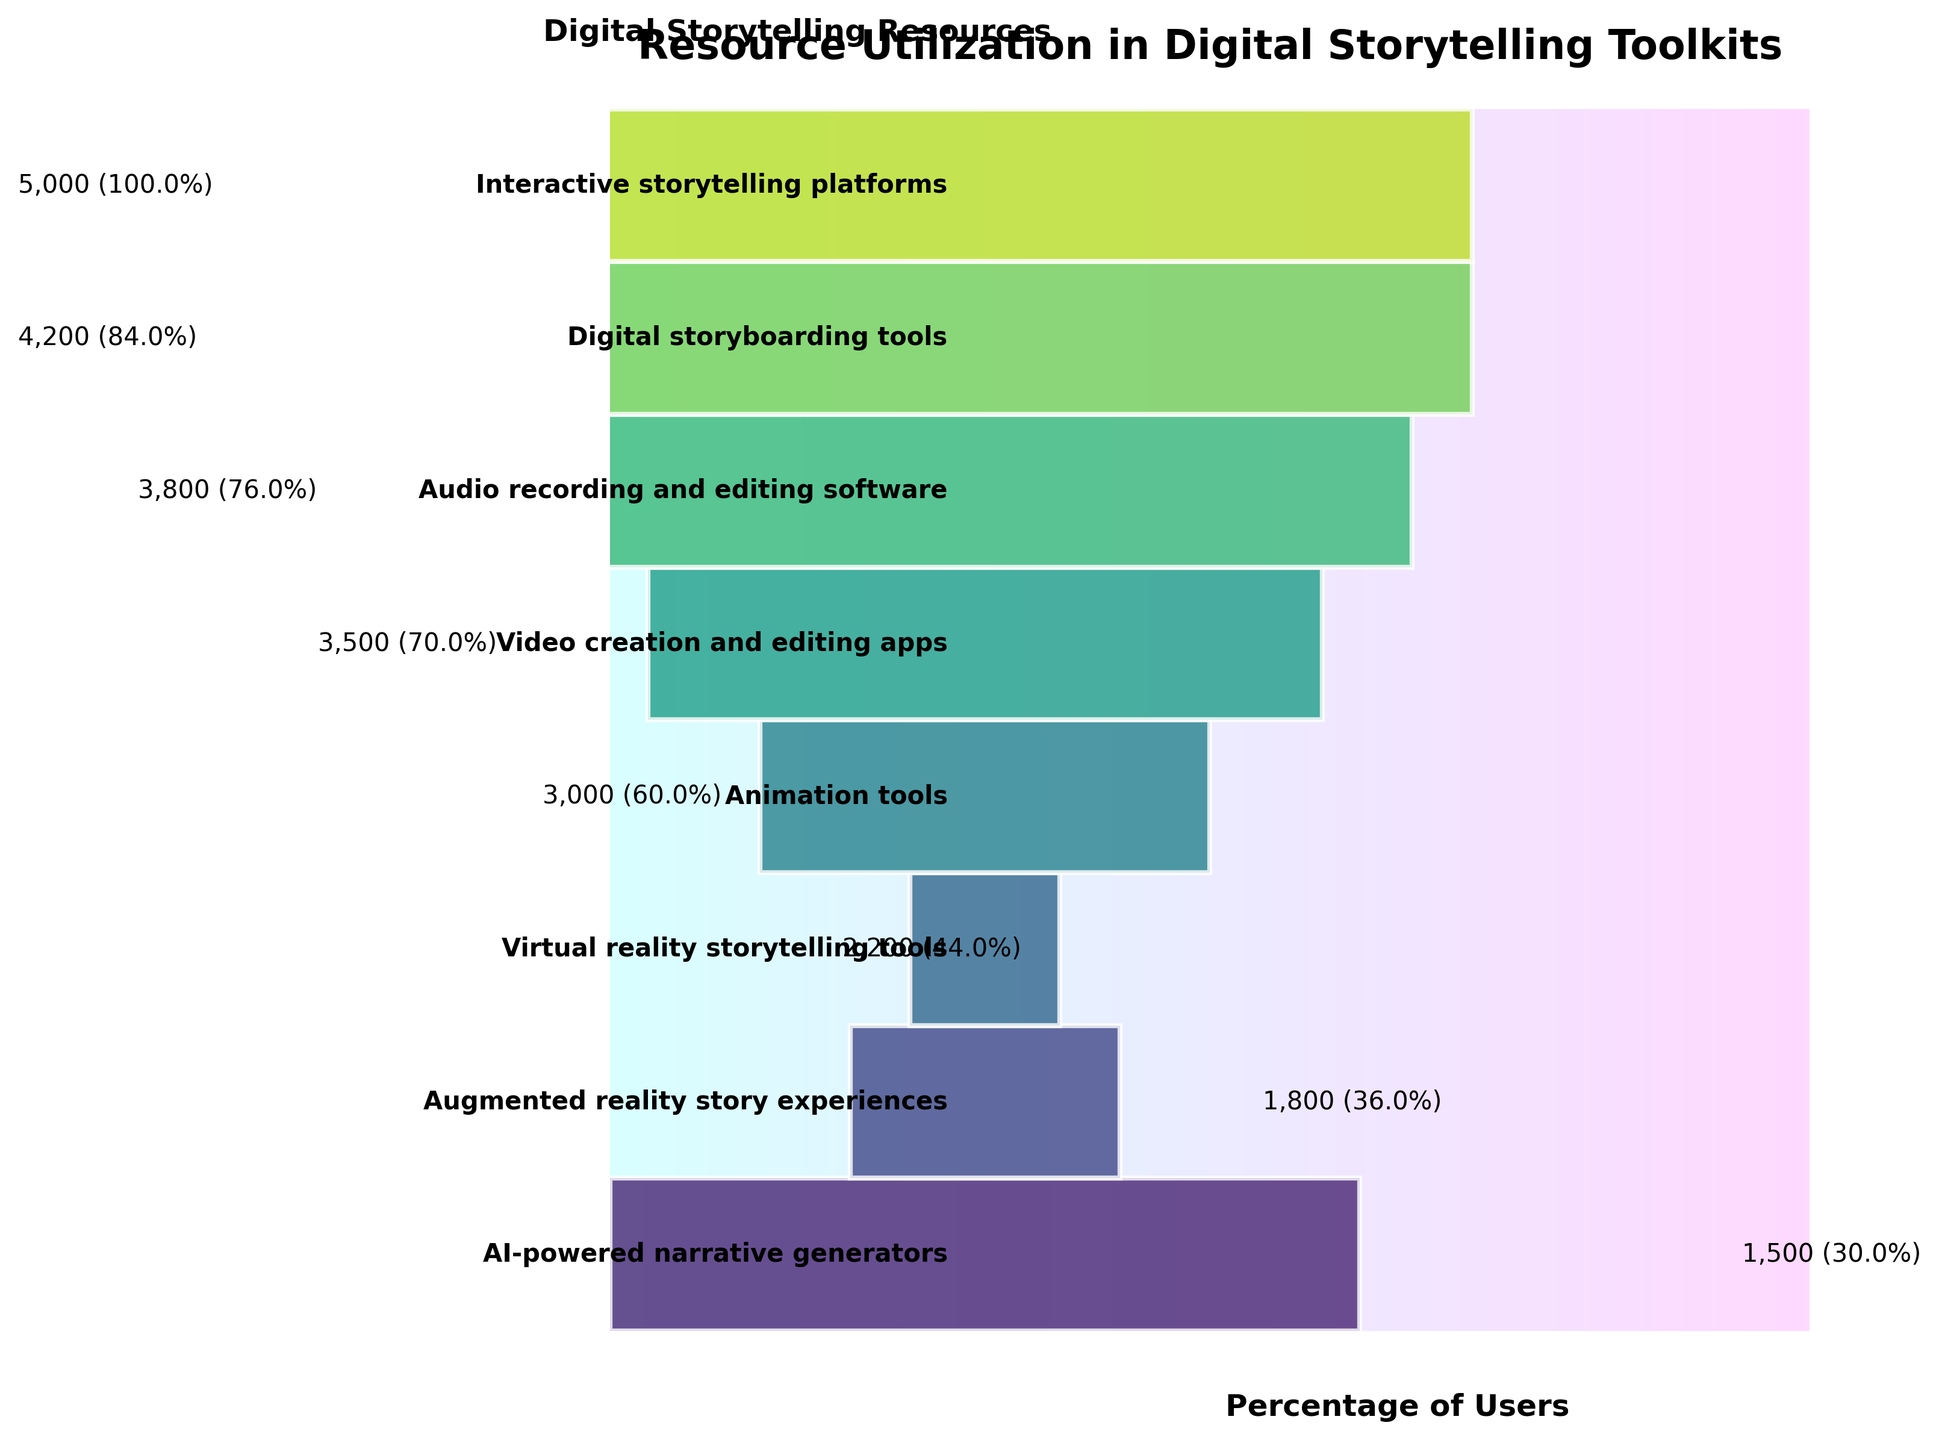What is the title of the chart? The title is usually displayed at the top of the chart. Reading the chart, the title clearly states the main topic of the visualization.
Answer: Resource Utilization in Digital Storytelling Toolkits How many resources are listed in the funnel chart? To determine this, count the number of distinct resource categories shown in the funnel chart.
Answer: 8 Which resource has the highest percentage of users? Find the segment with the widest width and observe the label associated with it. The highest percentage is the starting point of the funnel.
Answer: Interactive storytelling platforms How many users utilize Virtual reality storytelling tools? Locate the segment labeled "Virtual reality storytelling tools" and refer to the user count written next to it.
Answer: 2200 What is the difference in user count between Audio recording and editing software and Augmented reality story experiences? Identify the user counts for both resources from the segments and subtract the lower number from the higher number: 3800 - 1800.
Answer: 2000 What percentage of users utilize AI-powered narrative generators? Locate the segment titled "AI-powered narrative generators" and refer to the percentage displayed next to it.
Answer: 30% Which resource shows a 70% utilization rate? Find the segment in the funnel chart that displays a 70% utilization rate and note the resource associated with it.
Answer: Video creation and editing apps What is the average percentage utilization across all resources? Add all the percentages and divide by the number of resources: (100 + 84 + 76 + 70 + 60 + 44 + 36 + 30) / 8
Answer: 62.5% Which resources have a utilization percentage greater than 50%? Identify and list all segments with percentages displayed that are greater than 50%.
Answer: Interactive storytelling platforms, Digital storyboarding tools, Audio recording and editing software, Video creation and editing apps, Animation tools How many fewer users utilize Animation tools compared to Digital storyboarding tools? Subtract the number of users of Animation tools from that of Digital storyboarding tools: 4200 - 3000.
Answer: 1200 